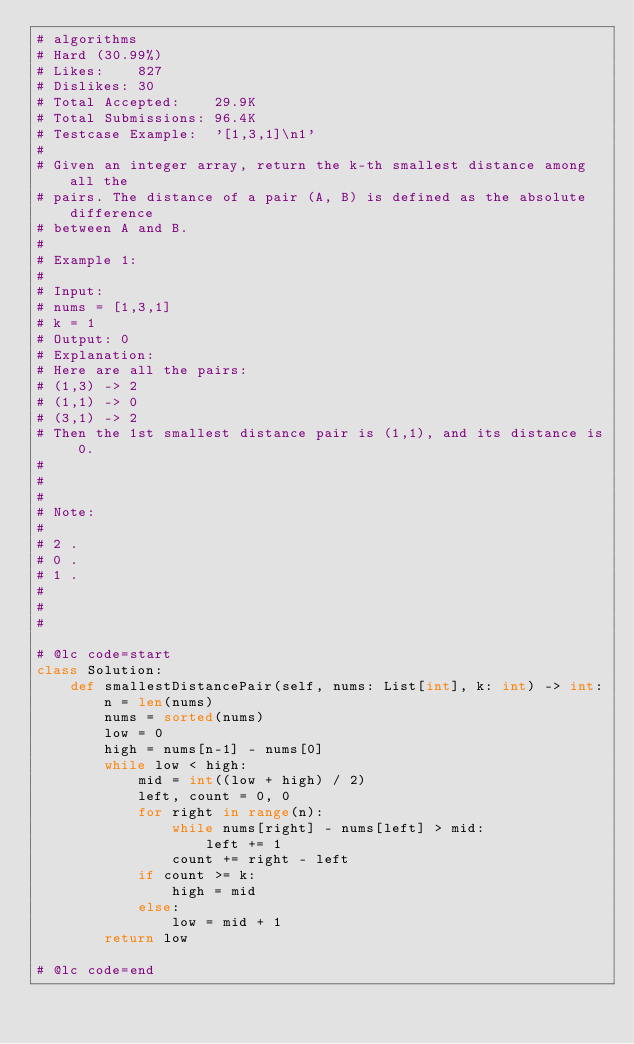<code> <loc_0><loc_0><loc_500><loc_500><_Python_># algorithms
# Hard (30.99%)
# Likes:    827
# Dislikes: 30
# Total Accepted:    29.9K
# Total Submissions: 96.4K
# Testcase Example:  '[1,3,1]\n1'
#
# Given an integer array, return the k-th smallest distance among all the
# pairs. The distance of a pair (A, B) is defined as the absolute difference
# between A and B. 
# 
# Example 1:
# 
# Input:
# nums = [1,3,1]
# k = 1
# Output: 0 
# Explanation:
# Here are all the pairs:
# (1,3) -> 2
# (1,1) -> 0
# (3,1) -> 2
# Then the 1st smallest distance pair is (1,1), and its distance is 0.
# 
# 
# 
# Note:
# 
# 2 .
# 0 .
# 1 .
# 
# 
#

# @lc code=start
class Solution:
    def smallestDistancePair(self, nums: List[int], k: int) -> int:
        n = len(nums)
        nums = sorted(nums)
        low = 0
        high = nums[n-1] - nums[0]
        while low < high:
            mid = int((low + high) / 2)
            left, count = 0, 0
            for right in range(n):
                while nums[right] - nums[left] > mid:
                    left += 1
                count += right - left
            if count >= k:
                high = mid
            else:
                low = mid + 1
        return low
            
# @lc code=end
</code> 